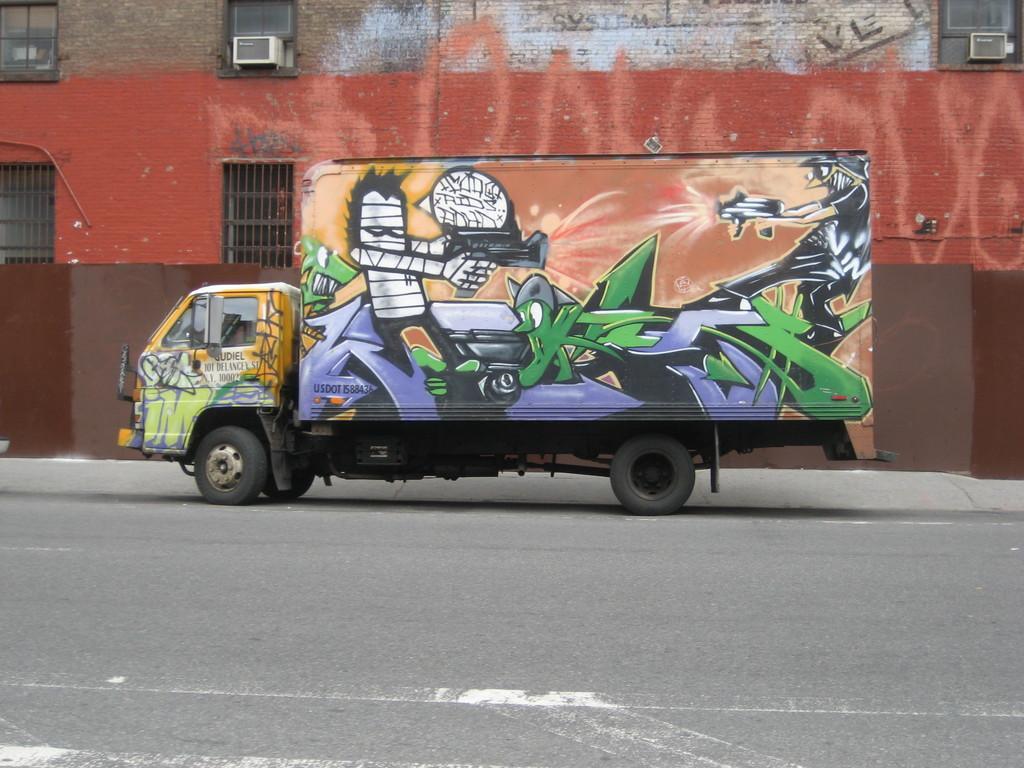Please provide a concise description of this image. In the center of the image, we can see a vehicle on the road and in the background, there is a building and we can see some air conditioners and there are windows. 